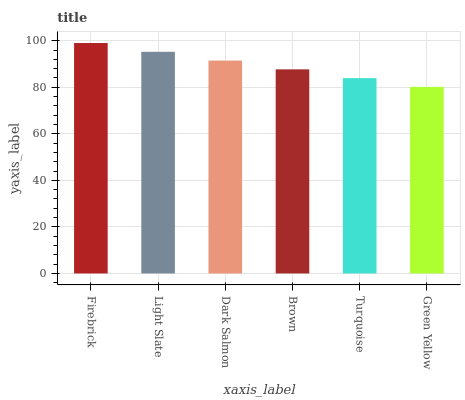Is Light Slate the minimum?
Answer yes or no. No. Is Light Slate the maximum?
Answer yes or no. No. Is Firebrick greater than Light Slate?
Answer yes or no. Yes. Is Light Slate less than Firebrick?
Answer yes or no. Yes. Is Light Slate greater than Firebrick?
Answer yes or no. No. Is Firebrick less than Light Slate?
Answer yes or no. No. Is Dark Salmon the high median?
Answer yes or no. Yes. Is Brown the low median?
Answer yes or no. Yes. Is Light Slate the high median?
Answer yes or no. No. Is Turquoise the low median?
Answer yes or no. No. 